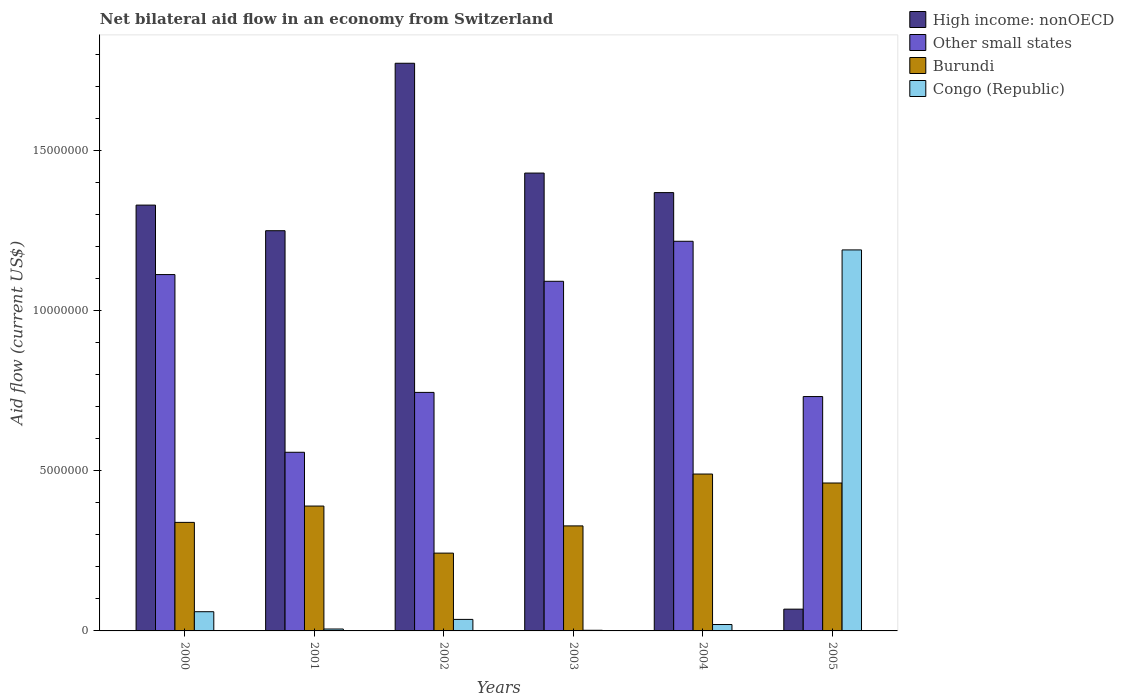How many different coloured bars are there?
Provide a short and direct response. 4. How many groups of bars are there?
Provide a short and direct response. 6. How many bars are there on the 5th tick from the left?
Offer a terse response. 4. What is the label of the 3rd group of bars from the left?
Provide a short and direct response. 2002. In how many cases, is the number of bars for a given year not equal to the number of legend labels?
Your answer should be compact. 0. What is the net bilateral aid flow in Other small states in 2000?
Keep it short and to the point. 1.11e+07. Across all years, what is the maximum net bilateral aid flow in Burundi?
Provide a short and direct response. 4.90e+06. Across all years, what is the minimum net bilateral aid flow in High income: nonOECD?
Provide a short and direct response. 6.80e+05. In which year was the net bilateral aid flow in Other small states minimum?
Offer a very short reply. 2001. What is the total net bilateral aid flow in Congo (Republic) in the graph?
Your response must be concise. 1.31e+07. What is the difference between the net bilateral aid flow in High income: nonOECD in 2001 and the net bilateral aid flow in Congo (Republic) in 2002?
Make the answer very short. 1.21e+07. What is the average net bilateral aid flow in Other small states per year?
Offer a very short reply. 9.10e+06. In the year 2003, what is the difference between the net bilateral aid flow in Burundi and net bilateral aid flow in High income: nonOECD?
Your response must be concise. -1.10e+07. What is the difference between the highest and the second highest net bilateral aid flow in Other small states?
Your answer should be very brief. 1.04e+06. What is the difference between the highest and the lowest net bilateral aid flow in High income: nonOECD?
Make the answer very short. 1.70e+07. In how many years, is the net bilateral aid flow in Other small states greater than the average net bilateral aid flow in Other small states taken over all years?
Provide a succinct answer. 3. Is the sum of the net bilateral aid flow in Burundi in 2002 and 2003 greater than the maximum net bilateral aid flow in Congo (Republic) across all years?
Your answer should be compact. No. Is it the case that in every year, the sum of the net bilateral aid flow in Congo (Republic) and net bilateral aid flow in High income: nonOECD is greater than the sum of net bilateral aid flow in Burundi and net bilateral aid flow in Other small states?
Keep it short and to the point. No. What does the 1st bar from the left in 2005 represents?
Offer a terse response. High income: nonOECD. What does the 3rd bar from the right in 2003 represents?
Give a very brief answer. Other small states. How many bars are there?
Make the answer very short. 24. How many years are there in the graph?
Ensure brevity in your answer.  6. What is the difference between two consecutive major ticks on the Y-axis?
Keep it short and to the point. 5.00e+06. Are the values on the major ticks of Y-axis written in scientific E-notation?
Provide a short and direct response. No. Does the graph contain grids?
Give a very brief answer. No. Where does the legend appear in the graph?
Give a very brief answer. Top right. What is the title of the graph?
Keep it short and to the point. Net bilateral aid flow in an economy from Switzerland. Does "Norway" appear as one of the legend labels in the graph?
Your answer should be very brief. No. What is the label or title of the Y-axis?
Ensure brevity in your answer.  Aid flow (current US$). What is the Aid flow (current US$) of High income: nonOECD in 2000?
Offer a terse response. 1.33e+07. What is the Aid flow (current US$) of Other small states in 2000?
Offer a terse response. 1.11e+07. What is the Aid flow (current US$) of Burundi in 2000?
Your answer should be very brief. 3.39e+06. What is the Aid flow (current US$) in High income: nonOECD in 2001?
Ensure brevity in your answer.  1.25e+07. What is the Aid flow (current US$) of Other small states in 2001?
Offer a terse response. 5.58e+06. What is the Aid flow (current US$) of Burundi in 2001?
Your response must be concise. 3.90e+06. What is the Aid flow (current US$) in Congo (Republic) in 2001?
Provide a short and direct response. 6.00e+04. What is the Aid flow (current US$) in High income: nonOECD in 2002?
Keep it short and to the point. 1.77e+07. What is the Aid flow (current US$) of Other small states in 2002?
Your response must be concise. 7.45e+06. What is the Aid flow (current US$) in Burundi in 2002?
Your answer should be very brief. 2.43e+06. What is the Aid flow (current US$) of Congo (Republic) in 2002?
Make the answer very short. 3.60e+05. What is the Aid flow (current US$) in High income: nonOECD in 2003?
Provide a succinct answer. 1.43e+07. What is the Aid flow (current US$) of Other small states in 2003?
Provide a succinct answer. 1.09e+07. What is the Aid flow (current US$) in Burundi in 2003?
Your answer should be compact. 3.28e+06. What is the Aid flow (current US$) of High income: nonOECD in 2004?
Make the answer very short. 1.37e+07. What is the Aid flow (current US$) in Other small states in 2004?
Your answer should be very brief. 1.22e+07. What is the Aid flow (current US$) in Burundi in 2004?
Keep it short and to the point. 4.90e+06. What is the Aid flow (current US$) of High income: nonOECD in 2005?
Offer a terse response. 6.80e+05. What is the Aid flow (current US$) in Other small states in 2005?
Your answer should be very brief. 7.32e+06. What is the Aid flow (current US$) in Burundi in 2005?
Provide a succinct answer. 4.62e+06. What is the Aid flow (current US$) of Congo (Republic) in 2005?
Give a very brief answer. 1.19e+07. Across all years, what is the maximum Aid flow (current US$) in High income: nonOECD?
Offer a very short reply. 1.77e+07. Across all years, what is the maximum Aid flow (current US$) in Other small states?
Provide a short and direct response. 1.22e+07. Across all years, what is the maximum Aid flow (current US$) in Burundi?
Your response must be concise. 4.90e+06. Across all years, what is the maximum Aid flow (current US$) in Congo (Republic)?
Keep it short and to the point. 1.19e+07. Across all years, what is the minimum Aid flow (current US$) in High income: nonOECD?
Ensure brevity in your answer.  6.80e+05. Across all years, what is the minimum Aid flow (current US$) of Other small states?
Your answer should be compact. 5.58e+06. Across all years, what is the minimum Aid flow (current US$) in Burundi?
Make the answer very short. 2.43e+06. Across all years, what is the minimum Aid flow (current US$) of Congo (Republic)?
Provide a succinct answer. 2.00e+04. What is the total Aid flow (current US$) in High income: nonOECD in the graph?
Your answer should be compact. 7.22e+07. What is the total Aid flow (current US$) in Other small states in the graph?
Your answer should be compact. 5.46e+07. What is the total Aid flow (current US$) in Burundi in the graph?
Your answer should be very brief. 2.25e+07. What is the total Aid flow (current US$) of Congo (Republic) in the graph?
Keep it short and to the point. 1.31e+07. What is the difference between the Aid flow (current US$) in High income: nonOECD in 2000 and that in 2001?
Your answer should be compact. 8.00e+05. What is the difference between the Aid flow (current US$) of Other small states in 2000 and that in 2001?
Keep it short and to the point. 5.55e+06. What is the difference between the Aid flow (current US$) of Burundi in 2000 and that in 2001?
Offer a terse response. -5.10e+05. What is the difference between the Aid flow (current US$) of Congo (Republic) in 2000 and that in 2001?
Your response must be concise. 5.40e+05. What is the difference between the Aid flow (current US$) in High income: nonOECD in 2000 and that in 2002?
Keep it short and to the point. -4.43e+06. What is the difference between the Aid flow (current US$) of Other small states in 2000 and that in 2002?
Your response must be concise. 3.68e+06. What is the difference between the Aid flow (current US$) of Burundi in 2000 and that in 2002?
Your answer should be very brief. 9.60e+05. What is the difference between the Aid flow (current US$) of Congo (Republic) in 2000 and that in 2002?
Your answer should be very brief. 2.40e+05. What is the difference between the Aid flow (current US$) in High income: nonOECD in 2000 and that in 2003?
Your answer should be compact. -1.00e+06. What is the difference between the Aid flow (current US$) of Other small states in 2000 and that in 2003?
Your response must be concise. 2.10e+05. What is the difference between the Aid flow (current US$) in Congo (Republic) in 2000 and that in 2003?
Provide a succinct answer. 5.80e+05. What is the difference between the Aid flow (current US$) of High income: nonOECD in 2000 and that in 2004?
Ensure brevity in your answer.  -3.90e+05. What is the difference between the Aid flow (current US$) of Other small states in 2000 and that in 2004?
Provide a short and direct response. -1.04e+06. What is the difference between the Aid flow (current US$) in Burundi in 2000 and that in 2004?
Your answer should be very brief. -1.51e+06. What is the difference between the Aid flow (current US$) of High income: nonOECD in 2000 and that in 2005?
Your answer should be compact. 1.26e+07. What is the difference between the Aid flow (current US$) in Other small states in 2000 and that in 2005?
Ensure brevity in your answer.  3.81e+06. What is the difference between the Aid flow (current US$) of Burundi in 2000 and that in 2005?
Your answer should be compact. -1.23e+06. What is the difference between the Aid flow (current US$) of Congo (Republic) in 2000 and that in 2005?
Your answer should be very brief. -1.13e+07. What is the difference between the Aid flow (current US$) in High income: nonOECD in 2001 and that in 2002?
Offer a terse response. -5.23e+06. What is the difference between the Aid flow (current US$) of Other small states in 2001 and that in 2002?
Keep it short and to the point. -1.87e+06. What is the difference between the Aid flow (current US$) of Burundi in 2001 and that in 2002?
Offer a very short reply. 1.47e+06. What is the difference between the Aid flow (current US$) of Congo (Republic) in 2001 and that in 2002?
Provide a succinct answer. -3.00e+05. What is the difference between the Aid flow (current US$) of High income: nonOECD in 2001 and that in 2003?
Provide a short and direct response. -1.80e+06. What is the difference between the Aid flow (current US$) in Other small states in 2001 and that in 2003?
Your response must be concise. -5.34e+06. What is the difference between the Aid flow (current US$) of Burundi in 2001 and that in 2003?
Provide a short and direct response. 6.20e+05. What is the difference between the Aid flow (current US$) of Congo (Republic) in 2001 and that in 2003?
Offer a terse response. 4.00e+04. What is the difference between the Aid flow (current US$) in High income: nonOECD in 2001 and that in 2004?
Offer a terse response. -1.19e+06. What is the difference between the Aid flow (current US$) in Other small states in 2001 and that in 2004?
Your response must be concise. -6.59e+06. What is the difference between the Aid flow (current US$) in Congo (Republic) in 2001 and that in 2004?
Ensure brevity in your answer.  -1.40e+05. What is the difference between the Aid flow (current US$) of High income: nonOECD in 2001 and that in 2005?
Make the answer very short. 1.18e+07. What is the difference between the Aid flow (current US$) in Other small states in 2001 and that in 2005?
Provide a succinct answer. -1.74e+06. What is the difference between the Aid flow (current US$) in Burundi in 2001 and that in 2005?
Provide a succinct answer. -7.20e+05. What is the difference between the Aid flow (current US$) in Congo (Republic) in 2001 and that in 2005?
Ensure brevity in your answer.  -1.18e+07. What is the difference between the Aid flow (current US$) in High income: nonOECD in 2002 and that in 2003?
Your answer should be very brief. 3.43e+06. What is the difference between the Aid flow (current US$) of Other small states in 2002 and that in 2003?
Your answer should be very brief. -3.47e+06. What is the difference between the Aid flow (current US$) in Burundi in 2002 and that in 2003?
Offer a terse response. -8.50e+05. What is the difference between the Aid flow (current US$) in Congo (Republic) in 2002 and that in 2003?
Offer a very short reply. 3.40e+05. What is the difference between the Aid flow (current US$) of High income: nonOECD in 2002 and that in 2004?
Provide a succinct answer. 4.04e+06. What is the difference between the Aid flow (current US$) in Other small states in 2002 and that in 2004?
Offer a very short reply. -4.72e+06. What is the difference between the Aid flow (current US$) in Burundi in 2002 and that in 2004?
Offer a very short reply. -2.47e+06. What is the difference between the Aid flow (current US$) in High income: nonOECD in 2002 and that in 2005?
Your response must be concise. 1.70e+07. What is the difference between the Aid flow (current US$) in Other small states in 2002 and that in 2005?
Keep it short and to the point. 1.30e+05. What is the difference between the Aid flow (current US$) in Burundi in 2002 and that in 2005?
Your answer should be very brief. -2.19e+06. What is the difference between the Aid flow (current US$) in Congo (Republic) in 2002 and that in 2005?
Offer a terse response. -1.15e+07. What is the difference between the Aid flow (current US$) of High income: nonOECD in 2003 and that in 2004?
Keep it short and to the point. 6.10e+05. What is the difference between the Aid flow (current US$) in Other small states in 2003 and that in 2004?
Your answer should be very brief. -1.25e+06. What is the difference between the Aid flow (current US$) of Burundi in 2003 and that in 2004?
Offer a very short reply. -1.62e+06. What is the difference between the Aid flow (current US$) in Congo (Republic) in 2003 and that in 2004?
Keep it short and to the point. -1.80e+05. What is the difference between the Aid flow (current US$) in High income: nonOECD in 2003 and that in 2005?
Make the answer very short. 1.36e+07. What is the difference between the Aid flow (current US$) of Other small states in 2003 and that in 2005?
Ensure brevity in your answer.  3.60e+06. What is the difference between the Aid flow (current US$) in Burundi in 2003 and that in 2005?
Your answer should be compact. -1.34e+06. What is the difference between the Aid flow (current US$) in Congo (Republic) in 2003 and that in 2005?
Offer a very short reply. -1.19e+07. What is the difference between the Aid flow (current US$) in High income: nonOECD in 2004 and that in 2005?
Your answer should be compact. 1.30e+07. What is the difference between the Aid flow (current US$) of Other small states in 2004 and that in 2005?
Offer a terse response. 4.85e+06. What is the difference between the Aid flow (current US$) of Congo (Republic) in 2004 and that in 2005?
Provide a succinct answer. -1.17e+07. What is the difference between the Aid flow (current US$) of High income: nonOECD in 2000 and the Aid flow (current US$) of Other small states in 2001?
Your response must be concise. 7.72e+06. What is the difference between the Aid flow (current US$) in High income: nonOECD in 2000 and the Aid flow (current US$) in Burundi in 2001?
Your answer should be very brief. 9.40e+06. What is the difference between the Aid flow (current US$) of High income: nonOECD in 2000 and the Aid flow (current US$) of Congo (Republic) in 2001?
Offer a terse response. 1.32e+07. What is the difference between the Aid flow (current US$) in Other small states in 2000 and the Aid flow (current US$) in Burundi in 2001?
Offer a very short reply. 7.23e+06. What is the difference between the Aid flow (current US$) of Other small states in 2000 and the Aid flow (current US$) of Congo (Republic) in 2001?
Ensure brevity in your answer.  1.11e+07. What is the difference between the Aid flow (current US$) of Burundi in 2000 and the Aid flow (current US$) of Congo (Republic) in 2001?
Make the answer very short. 3.33e+06. What is the difference between the Aid flow (current US$) of High income: nonOECD in 2000 and the Aid flow (current US$) of Other small states in 2002?
Provide a succinct answer. 5.85e+06. What is the difference between the Aid flow (current US$) of High income: nonOECD in 2000 and the Aid flow (current US$) of Burundi in 2002?
Your answer should be compact. 1.09e+07. What is the difference between the Aid flow (current US$) in High income: nonOECD in 2000 and the Aid flow (current US$) in Congo (Republic) in 2002?
Keep it short and to the point. 1.29e+07. What is the difference between the Aid flow (current US$) in Other small states in 2000 and the Aid flow (current US$) in Burundi in 2002?
Your answer should be very brief. 8.70e+06. What is the difference between the Aid flow (current US$) in Other small states in 2000 and the Aid flow (current US$) in Congo (Republic) in 2002?
Give a very brief answer. 1.08e+07. What is the difference between the Aid flow (current US$) of Burundi in 2000 and the Aid flow (current US$) of Congo (Republic) in 2002?
Your answer should be compact. 3.03e+06. What is the difference between the Aid flow (current US$) of High income: nonOECD in 2000 and the Aid flow (current US$) of Other small states in 2003?
Your answer should be compact. 2.38e+06. What is the difference between the Aid flow (current US$) in High income: nonOECD in 2000 and the Aid flow (current US$) in Burundi in 2003?
Offer a terse response. 1.00e+07. What is the difference between the Aid flow (current US$) in High income: nonOECD in 2000 and the Aid flow (current US$) in Congo (Republic) in 2003?
Your answer should be compact. 1.33e+07. What is the difference between the Aid flow (current US$) of Other small states in 2000 and the Aid flow (current US$) of Burundi in 2003?
Provide a succinct answer. 7.85e+06. What is the difference between the Aid flow (current US$) in Other small states in 2000 and the Aid flow (current US$) in Congo (Republic) in 2003?
Give a very brief answer. 1.11e+07. What is the difference between the Aid flow (current US$) of Burundi in 2000 and the Aid flow (current US$) of Congo (Republic) in 2003?
Ensure brevity in your answer.  3.37e+06. What is the difference between the Aid flow (current US$) in High income: nonOECD in 2000 and the Aid flow (current US$) in Other small states in 2004?
Give a very brief answer. 1.13e+06. What is the difference between the Aid flow (current US$) in High income: nonOECD in 2000 and the Aid flow (current US$) in Burundi in 2004?
Provide a succinct answer. 8.40e+06. What is the difference between the Aid flow (current US$) in High income: nonOECD in 2000 and the Aid flow (current US$) in Congo (Republic) in 2004?
Ensure brevity in your answer.  1.31e+07. What is the difference between the Aid flow (current US$) of Other small states in 2000 and the Aid flow (current US$) of Burundi in 2004?
Provide a succinct answer. 6.23e+06. What is the difference between the Aid flow (current US$) in Other small states in 2000 and the Aid flow (current US$) in Congo (Republic) in 2004?
Offer a terse response. 1.09e+07. What is the difference between the Aid flow (current US$) in Burundi in 2000 and the Aid flow (current US$) in Congo (Republic) in 2004?
Offer a terse response. 3.19e+06. What is the difference between the Aid flow (current US$) of High income: nonOECD in 2000 and the Aid flow (current US$) of Other small states in 2005?
Offer a terse response. 5.98e+06. What is the difference between the Aid flow (current US$) of High income: nonOECD in 2000 and the Aid flow (current US$) of Burundi in 2005?
Your answer should be very brief. 8.68e+06. What is the difference between the Aid flow (current US$) in High income: nonOECD in 2000 and the Aid flow (current US$) in Congo (Republic) in 2005?
Offer a very short reply. 1.40e+06. What is the difference between the Aid flow (current US$) of Other small states in 2000 and the Aid flow (current US$) of Burundi in 2005?
Offer a very short reply. 6.51e+06. What is the difference between the Aid flow (current US$) of Other small states in 2000 and the Aid flow (current US$) of Congo (Republic) in 2005?
Keep it short and to the point. -7.70e+05. What is the difference between the Aid flow (current US$) in Burundi in 2000 and the Aid flow (current US$) in Congo (Republic) in 2005?
Keep it short and to the point. -8.51e+06. What is the difference between the Aid flow (current US$) in High income: nonOECD in 2001 and the Aid flow (current US$) in Other small states in 2002?
Your response must be concise. 5.05e+06. What is the difference between the Aid flow (current US$) in High income: nonOECD in 2001 and the Aid flow (current US$) in Burundi in 2002?
Your answer should be very brief. 1.01e+07. What is the difference between the Aid flow (current US$) in High income: nonOECD in 2001 and the Aid flow (current US$) in Congo (Republic) in 2002?
Ensure brevity in your answer.  1.21e+07. What is the difference between the Aid flow (current US$) of Other small states in 2001 and the Aid flow (current US$) of Burundi in 2002?
Provide a short and direct response. 3.15e+06. What is the difference between the Aid flow (current US$) of Other small states in 2001 and the Aid flow (current US$) of Congo (Republic) in 2002?
Offer a terse response. 5.22e+06. What is the difference between the Aid flow (current US$) of Burundi in 2001 and the Aid flow (current US$) of Congo (Republic) in 2002?
Provide a succinct answer. 3.54e+06. What is the difference between the Aid flow (current US$) in High income: nonOECD in 2001 and the Aid flow (current US$) in Other small states in 2003?
Ensure brevity in your answer.  1.58e+06. What is the difference between the Aid flow (current US$) of High income: nonOECD in 2001 and the Aid flow (current US$) of Burundi in 2003?
Offer a very short reply. 9.22e+06. What is the difference between the Aid flow (current US$) in High income: nonOECD in 2001 and the Aid flow (current US$) in Congo (Republic) in 2003?
Keep it short and to the point. 1.25e+07. What is the difference between the Aid flow (current US$) in Other small states in 2001 and the Aid flow (current US$) in Burundi in 2003?
Ensure brevity in your answer.  2.30e+06. What is the difference between the Aid flow (current US$) in Other small states in 2001 and the Aid flow (current US$) in Congo (Republic) in 2003?
Provide a succinct answer. 5.56e+06. What is the difference between the Aid flow (current US$) of Burundi in 2001 and the Aid flow (current US$) of Congo (Republic) in 2003?
Provide a short and direct response. 3.88e+06. What is the difference between the Aid flow (current US$) of High income: nonOECD in 2001 and the Aid flow (current US$) of Other small states in 2004?
Provide a short and direct response. 3.30e+05. What is the difference between the Aid flow (current US$) of High income: nonOECD in 2001 and the Aid flow (current US$) of Burundi in 2004?
Provide a short and direct response. 7.60e+06. What is the difference between the Aid flow (current US$) in High income: nonOECD in 2001 and the Aid flow (current US$) in Congo (Republic) in 2004?
Your answer should be very brief. 1.23e+07. What is the difference between the Aid flow (current US$) in Other small states in 2001 and the Aid flow (current US$) in Burundi in 2004?
Make the answer very short. 6.80e+05. What is the difference between the Aid flow (current US$) in Other small states in 2001 and the Aid flow (current US$) in Congo (Republic) in 2004?
Your answer should be very brief. 5.38e+06. What is the difference between the Aid flow (current US$) of Burundi in 2001 and the Aid flow (current US$) of Congo (Republic) in 2004?
Provide a succinct answer. 3.70e+06. What is the difference between the Aid flow (current US$) in High income: nonOECD in 2001 and the Aid flow (current US$) in Other small states in 2005?
Your answer should be very brief. 5.18e+06. What is the difference between the Aid flow (current US$) in High income: nonOECD in 2001 and the Aid flow (current US$) in Burundi in 2005?
Ensure brevity in your answer.  7.88e+06. What is the difference between the Aid flow (current US$) in Other small states in 2001 and the Aid flow (current US$) in Burundi in 2005?
Your response must be concise. 9.60e+05. What is the difference between the Aid flow (current US$) in Other small states in 2001 and the Aid flow (current US$) in Congo (Republic) in 2005?
Provide a succinct answer. -6.32e+06. What is the difference between the Aid flow (current US$) of Burundi in 2001 and the Aid flow (current US$) of Congo (Republic) in 2005?
Provide a succinct answer. -8.00e+06. What is the difference between the Aid flow (current US$) of High income: nonOECD in 2002 and the Aid flow (current US$) of Other small states in 2003?
Give a very brief answer. 6.81e+06. What is the difference between the Aid flow (current US$) in High income: nonOECD in 2002 and the Aid flow (current US$) in Burundi in 2003?
Your answer should be very brief. 1.44e+07. What is the difference between the Aid flow (current US$) of High income: nonOECD in 2002 and the Aid flow (current US$) of Congo (Republic) in 2003?
Your answer should be very brief. 1.77e+07. What is the difference between the Aid flow (current US$) of Other small states in 2002 and the Aid flow (current US$) of Burundi in 2003?
Your response must be concise. 4.17e+06. What is the difference between the Aid flow (current US$) of Other small states in 2002 and the Aid flow (current US$) of Congo (Republic) in 2003?
Your answer should be compact. 7.43e+06. What is the difference between the Aid flow (current US$) of Burundi in 2002 and the Aid flow (current US$) of Congo (Republic) in 2003?
Keep it short and to the point. 2.41e+06. What is the difference between the Aid flow (current US$) in High income: nonOECD in 2002 and the Aid flow (current US$) in Other small states in 2004?
Make the answer very short. 5.56e+06. What is the difference between the Aid flow (current US$) in High income: nonOECD in 2002 and the Aid flow (current US$) in Burundi in 2004?
Provide a short and direct response. 1.28e+07. What is the difference between the Aid flow (current US$) in High income: nonOECD in 2002 and the Aid flow (current US$) in Congo (Republic) in 2004?
Offer a terse response. 1.75e+07. What is the difference between the Aid flow (current US$) in Other small states in 2002 and the Aid flow (current US$) in Burundi in 2004?
Your response must be concise. 2.55e+06. What is the difference between the Aid flow (current US$) of Other small states in 2002 and the Aid flow (current US$) of Congo (Republic) in 2004?
Provide a succinct answer. 7.25e+06. What is the difference between the Aid flow (current US$) of Burundi in 2002 and the Aid flow (current US$) of Congo (Republic) in 2004?
Make the answer very short. 2.23e+06. What is the difference between the Aid flow (current US$) of High income: nonOECD in 2002 and the Aid flow (current US$) of Other small states in 2005?
Your response must be concise. 1.04e+07. What is the difference between the Aid flow (current US$) of High income: nonOECD in 2002 and the Aid flow (current US$) of Burundi in 2005?
Ensure brevity in your answer.  1.31e+07. What is the difference between the Aid flow (current US$) of High income: nonOECD in 2002 and the Aid flow (current US$) of Congo (Republic) in 2005?
Offer a very short reply. 5.83e+06. What is the difference between the Aid flow (current US$) in Other small states in 2002 and the Aid flow (current US$) in Burundi in 2005?
Make the answer very short. 2.83e+06. What is the difference between the Aid flow (current US$) in Other small states in 2002 and the Aid flow (current US$) in Congo (Republic) in 2005?
Your answer should be compact. -4.45e+06. What is the difference between the Aid flow (current US$) of Burundi in 2002 and the Aid flow (current US$) of Congo (Republic) in 2005?
Give a very brief answer. -9.47e+06. What is the difference between the Aid flow (current US$) of High income: nonOECD in 2003 and the Aid flow (current US$) of Other small states in 2004?
Your answer should be very brief. 2.13e+06. What is the difference between the Aid flow (current US$) in High income: nonOECD in 2003 and the Aid flow (current US$) in Burundi in 2004?
Keep it short and to the point. 9.40e+06. What is the difference between the Aid flow (current US$) of High income: nonOECD in 2003 and the Aid flow (current US$) of Congo (Republic) in 2004?
Make the answer very short. 1.41e+07. What is the difference between the Aid flow (current US$) of Other small states in 2003 and the Aid flow (current US$) of Burundi in 2004?
Ensure brevity in your answer.  6.02e+06. What is the difference between the Aid flow (current US$) of Other small states in 2003 and the Aid flow (current US$) of Congo (Republic) in 2004?
Provide a short and direct response. 1.07e+07. What is the difference between the Aid flow (current US$) in Burundi in 2003 and the Aid flow (current US$) in Congo (Republic) in 2004?
Make the answer very short. 3.08e+06. What is the difference between the Aid flow (current US$) in High income: nonOECD in 2003 and the Aid flow (current US$) in Other small states in 2005?
Keep it short and to the point. 6.98e+06. What is the difference between the Aid flow (current US$) in High income: nonOECD in 2003 and the Aid flow (current US$) in Burundi in 2005?
Offer a terse response. 9.68e+06. What is the difference between the Aid flow (current US$) in High income: nonOECD in 2003 and the Aid flow (current US$) in Congo (Republic) in 2005?
Your response must be concise. 2.40e+06. What is the difference between the Aid flow (current US$) in Other small states in 2003 and the Aid flow (current US$) in Burundi in 2005?
Provide a succinct answer. 6.30e+06. What is the difference between the Aid flow (current US$) in Other small states in 2003 and the Aid flow (current US$) in Congo (Republic) in 2005?
Provide a succinct answer. -9.80e+05. What is the difference between the Aid flow (current US$) of Burundi in 2003 and the Aid flow (current US$) of Congo (Republic) in 2005?
Ensure brevity in your answer.  -8.62e+06. What is the difference between the Aid flow (current US$) of High income: nonOECD in 2004 and the Aid flow (current US$) of Other small states in 2005?
Ensure brevity in your answer.  6.37e+06. What is the difference between the Aid flow (current US$) of High income: nonOECD in 2004 and the Aid flow (current US$) of Burundi in 2005?
Give a very brief answer. 9.07e+06. What is the difference between the Aid flow (current US$) of High income: nonOECD in 2004 and the Aid flow (current US$) of Congo (Republic) in 2005?
Your response must be concise. 1.79e+06. What is the difference between the Aid flow (current US$) of Other small states in 2004 and the Aid flow (current US$) of Burundi in 2005?
Provide a short and direct response. 7.55e+06. What is the difference between the Aid flow (current US$) of Other small states in 2004 and the Aid flow (current US$) of Congo (Republic) in 2005?
Your answer should be compact. 2.70e+05. What is the difference between the Aid flow (current US$) in Burundi in 2004 and the Aid flow (current US$) in Congo (Republic) in 2005?
Your answer should be very brief. -7.00e+06. What is the average Aid flow (current US$) of High income: nonOECD per year?
Provide a short and direct response. 1.20e+07. What is the average Aid flow (current US$) in Other small states per year?
Offer a very short reply. 9.10e+06. What is the average Aid flow (current US$) of Burundi per year?
Give a very brief answer. 3.75e+06. What is the average Aid flow (current US$) in Congo (Republic) per year?
Provide a succinct answer. 2.19e+06. In the year 2000, what is the difference between the Aid flow (current US$) of High income: nonOECD and Aid flow (current US$) of Other small states?
Keep it short and to the point. 2.17e+06. In the year 2000, what is the difference between the Aid flow (current US$) of High income: nonOECD and Aid flow (current US$) of Burundi?
Make the answer very short. 9.91e+06. In the year 2000, what is the difference between the Aid flow (current US$) in High income: nonOECD and Aid flow (current US$) in Congo (Republic)?
Offer a terse response. 1.27e+07. In the year 2000, what is the difference between the Aid flow (current US$) of Other small states and Aid flow (current US$) of Burundi?
Your response must be concise. 7.74e+06. In the year 2000, what is the difference between the Aid flow (current US$) in Other small states and Aid flow (current US$) in Congo (Republic)?
Offer a very short reply. 1.05e+07. In the year 2000, what is the difference between the Aid flow (current US$) in Burundi and Aid flow (current US$) in Congo (Republic)?
Provide a short and direct response. 2.79e+06. In the year 2001, what is the difference between the Aid flow (current US$) in High income: nonOECD and Aid flow (current US$) in Other small states?
Keep it short and to the point. 6.92e+06. In the year 2001, what is the difference between the Aid flow (current US$) in High income: nonOECD and Aid flow (current US$) in Burundi?
Your response must be concise. 8.60e+06. In the year 2001, what is the difference between the Aid flow (current US$) in High income: nonOECD and Aid flow (current US$) in Congo (Republic)?
Offer a very short reply. 1.24e+07. In the year 2001, what is the difference between the Aid flow (current US$) in Other small states and Aid flow (current US$) in Burundi?
Make the answer very short. 1.68e+06. In the year 2001, what is the difference between the Aid flow (current US$) in Other small states and Aid flow (current US$) in Congo (Republic)?
Your answer should be very brief. 5.52e+06. In the year 2001, what is the difference between the Aid flow (current US$) of Burundi and Aid flow (current US$) of Congo (Republic)?
Offer a terse response. 3.84e+06. In the year 2002, what is the difference between the Aid flow (current US$) of High income: nonOECD and Aid flow (current US$) of Other small states?
Make the answer very short. 1.03e+07. In the year 2002, what is the difference between the Aid flow (current US$) in High income: nonOECD and Aid flow (current US$) in Burundi?
Provide a short and direct response. 1.53e+07. In the year 2002, what is the difference between the Aid flow (current US$) of High income: nonOECD and Aid flow (current US$) of Congo (Republic)?
Provide a short and direct response. 1.74e+07. In the year 2002, what is the difference between the Aid flow (current US$) in Other small states and Aid flow (current US$) in Burundi?
Provide a succinct answer. 5.02e+06. In the year 2002, what is the difference between the Aid flow (current US$) of Other small states and Aid flow (current US$) of Congo (Republic)?
Offer a very short reply. 7.09e+06. In the year 2002, what is the difference between the Aid flow (current US$) in Burundi and Aid flow (current US$) in Congo (Republic)?
Offer a terse response. 2.07e+06. In the year 2003, what is the difference between the Aid flow (current US$) in High income: nonOECD and Aid flow (current US$) in Other small states?
Your response must be concise. 3.38e+06. In the year 2003, what is the difference between the Aid flow (current US$) in High income: nonOECD and Aid flow (current US$) in Burundi?
Make the answer very short. 1.10e+07. In the year 2003, what is the difference between the Aid flow (current US$) of High income: nonOECD and Aid flow (current US$) of Congo (Republic)?
Offer a terse response. 1.43e+07. In the year 2003, what is the difference between the Aid flow (current US$) of Other small states and Aid flow (current US$) of Burundi?
Provide a succinct answer. 7.64e+06. In the year 2003, what is the difference between the Aid flow (current US$) of Other small states and Aid flow (current US$) of Congo (Republic)?
Offer a very short reply. 1.09e+07. In the year 2003, what is the difference between the Aid flow (current US$) of Burundi and Aid flow (current US$) of Congo (Republic)?
Make the answer very short. 3.26e+06. In the year 2004, what is the difference between the Aid flow (current US$) of High income: nonOECD and Aid flow (current US$) of Other small states?
Offer a very short reply. 1.52e+06. In the year 2004, what is the difference between the Aid flow (current US$) of High income: nonOECD and Aid flow (current US$) of Burundi?
Your answer should be compact. 8.79e+06. In the year 2004, what is the difference between the Aid flow (current US$) in High income: nonOECD and Aid flow (current US$) in Congo (Republic)?
Your response must be concise. 1.35e+07. In the year 2004, what is the difference between the Aid flow (current US$) of Other small states and Aid flow (current US$) of Burundi?
Give a very brief answer. 7.27e+06. In the year 2004, what is the difference between the Aid flow (current US$) of Other small states and Aid flow (current US$) of Congo (Republic)?
Your answer should be very brief. 1.20e+07. In the year 2004, what is the difference between the Aid flow (current US$) in Burundi and Aid flow (current US$) in Congo (Republic)?
Your answer should be compact. 4.70e+06. In the year 2005, what is the difference between the Aid flow (current US$) of High income: nonOECD and Aid flow (current US$) of Other small states?
Your response must be concise. -6.64e+06. In the year 2005, what is the difference between the Aid flow (current US$) of High income: nonOECD and Aid flow (current US$) of Burundi?
Offer a terse response. -3.94e+06. In the year 2005, what is the difference between the Aid flow (current US$) of High income: nonOECD and Aid flow (current US$) of Congo (Republic)?
Make the answer very short. -1.12e+07. In the year 2005, what is the difference between the Aid flow (current US$) of Other small states and Aid flow (current US$) of Burundi?
Ensure brevity in your answer.  2.70e+06. In the year 2005, what is the difference between the Aid flow (current US$) in Other small states and Aid flow (current US$) in Congo (Republic)?
Your response must be concise. -4.58e+06. In the year 2005, what is the difference between the Aid flow (current US$) in Burundi and Aid flow (current US$) in Congo (Republic)?
Your answer should be compact. -7.28e+06. What is the ratio of the Aid flow (current US$) in High income: nonOECD in 2000 to that in 2001?
Provide a short and direct response. 1.06. What is the ratio of the Aid flow (current US$) of Other small states in 2000 to that in 2001?
Keep it short and to the point. 1.99. What is the ratio of the Aid flow (current US$) in Burundi in 2000 to that in 2001?
Keep it short and to the point. 0.87. What is the ratio of the Aid flow (current US$) in Congo (Republic) in 2000 to that in 2001?
Give a very brief answer. 10. What is the ratio of the Aid flow (current US$) of High income: nonOECD in 2000 to that in 2002?
Your response must be concise. 0.75. What is the ratio of the Aid flow (current US$) in Other small states in 2000 to that in 2002?
Your response must be concise. 1.49. What is the ratio of the Aid flow (current US$) of Burundi in 2000 to that in 2002?
Your answer should be very brief. 1.4. What is the ratio of the Aid flow (current US$) in Congo (Republic) in 2000 to that in 2002?
Keep it short and to the point. 1.67. What is the ratio of the Aid flow (current US$) in High income: nonOECD in 2000 to that in 2003?
Ensure brevity in your answer.  0.93. What is the ratio of the Aid flow (current US$) in Other small states in 2000 to that in 2003?
Ensure brevity in your answer.  1.02. What is the ratio of the Aid flow (current US$) of Burundi in 2000 to that in 2003?
Provide a short and direct response. 1.03. What is the ratio of the Aid flow (current US$) in Congo (Republic) in 2000 to that in 2003?
Provide a succinct answer. 30. What is the ratio of the Aid flow (current US$) of High income: nonOECD in 2000 to that in 2004?
Make the answer very short. 0.97. What is the ratio of the Aid flow (current US$) in Other small states in 2000 to that in 2004?
Keep it short and to the point. 0.91. What is the ratio of the Aid flow (current US$) in Burundi in 2000 to that in 2004?
Provide a short and direct response. 0.69. What is the ratio of the Aid flow (current US$) in High income: nonOECD in 2000 to that in 2005?
Ensure brevity in your answer.  19.56. What is the ratio of the Aid flow (current US$) of Other small states in 2000 to that in 2005?
Make the answer very short. 1.52. What is the ratio of the Aid flow (current US$) of Burundi in 2000 to that in 2005?
Your answer should be very brief. 0.73. What is the ratio of the Aid flow (current US$) of Congo (Republic) in 2000 to that in 2005?
Keep it short and to the point. 0.05. What is the ratio of the Aid flow (current US$) of High income: nonOECD in 2001 to that in 2002?
Make the answer very short. 0.7. What is the ratio of the Aid flow (current US$) of Other small states in 2001 to that in 2002?
Provide a short and direct response. 0.75. What is the ratio of the Aid flow (current US$) in Burundi in 2001 to that in 2002?
Keep it short and to the point. 1.6. What is the ratio of the Aid flow (current US$) of High income: nonOECD in 2001 to that in 2003?
Keep it short and to the point. 0.87. What is the ratio of the Aid flow (current US$) of Other small states in 2001 to that in 2003?
Your response must be concise. 0.51. What is the ratio of the Aid flow (current US$) of Burundi in 2001 to that in 2003?
Your answer should be very brief. 1.19. What is the ratio of the Aid flow (current US$) in Congo (Republic) in 2001 to that in 2003?
Ensure brevity in your answer.  3. What is the ratio of the Aid flow (current US$) in High income: nonOECD in 2001 to that in 2004?
Your answer should be very brief. 0.91. What is the ratio of the Aid flow (current US$) of Other small states in 2001 to that in 2004?
Ensure brevity in your answer.  0.46. What is the ratio of the Aid flow (current US$) of Burundi in 2001 to that in 2004?
Offer a terse response. 0.8. What is the ratio of the Aid flow (current US$) of High income: nonOECD in 2001 to that in 2005?
Your response must be concise. 18.38. What is the ratio of the Aid flow (current US$) in Other small states in 2001 to that in 2005?
Keep it short and to the point. 0.76. What is the ratio of the Aid flow (current US$) of Burundi in 2001 to that in 2005?
Provide a short and direct response. 0.84. What is the ratio of the Aid flow (current US$) of Congo (Republic) in 2001 to that in 2005?
Provide a succinct answer. 0.01. What is the ratio of the Aid flow (current US$) of High income: nonOECD in 2002 to that in 2003?
Your answer should be compact. 1.24. What is the ratio of the Aid flow (current US$) in Other small states in 2002 to that in 2003?
Offer a terse response. 0.68. What is the ratio of the Aid flow (current US$) in Burundi in 2002 to that in 2003?
Ensure brevity in your answer.  0.74. What is the ratio of the Aid flow (current US$) of High income: nonOECD in 2002 to that in 2004?
Ensure brevity in your answer.  1.3. What is the ratio of the Aid flow (current US$) in Other small states in 2002 to that in 2004?
Offer a very short reply. 0.61. What is the ratio of the Aid flow (current US$) in Burundi in 2002 to that in 2004?
Your response must be concise. 0.5. What is the ratio of the Aid flow (current US$) in Congo (Republic) in 2002 to that in 2004?
Keep it short and to the point. 1.8. What is the ratio of the Aid flow (current US$) of High income: nonOECD in 2002 to that in 2005?
Provide a short and direct response. 26.07. What is the ratio of the Aid flow (current US$) in Other small states in 2002 to that in 2005?
Ensure brevity in your answer.  1.02. What is the ratio of the Aid flow (current US$) in Burundi in 2002 to that in 2005?
Give a very brief answer. 0.53. What is the ratio of the Aid flow (current US$) of Congo (Republic) in 2002 to that in 2005?
Provide a succinct answer. 0.03. What is the ratio of the Aid flow (current US$) in High income: nonOECD in 2003 to that in 2004?
Offer a terse response. 1.04. What is the ratio of the Aid flow (current US$) of Other small states in 2003 to that in 2004?
Offer a very short reply. 0.9. What is the ratio of the Aid flow (current US$) in Burundi in 2003 to that in 2004?
Your answer should be very brief. 0.67. What is the ratio of the Aid flow (current US$) of High income: nonOECD in 2003 to that in 2005?
Keep it short and to the point. 21.03. What is the ratio of the Aid flow (current US$) of Other small states in 2003 to that in 2005?
Make the answer very short. 1.49. What is the ratio of the Aid flow (current US$) of Burundi in 2003 to that in 2005?
Make the answer very short. 0.71. What is the ratio of the Aid flow (current US$) in Congo (Republic) in 2003 to that in 2005?
Your answer should be very brief. 0. What is the ratio of the Aid flow (current US$) of High income: nonOECD in 2004 to that in 2005?
Offer a very short reply. 20.13. What is the ratio of the Aid flow (current US$) in Other small states in 2004 to that in 2005?
Provide a succinct answer. 1.66. What is the ratio of the Aid flow (current US$) in Burundi in 2004 to that in 2005?
Offer a terse response. 1.06. What is the ratio of the Aid flow (current US$) in Congo (Republic) in 2004 to that in 2005?
Keep it short and to the point. 0.02. What is the difference between the highest and the second highest Aid flow (current US$) of High income: nonOECD?
Your answer should be very brief. 3.43e+06. What is the difference between the highest and the second highest Aid flow (current US$) of Other small states?
Give a very brief answer. 1.04e+06. What is the difference between the highest and the second highest Aid flow (current US$) of Burundi?
Keep it short and to the point. 2.80e+05. What is the difference between the highest and the second highest Aid flow (current US$) of Congo (Republic)?
Offer a terse response. 1.13e+07. What is the difference between the highest and the lowest Aid flow (current US$) in High income: nonOECD?
Your answer should be very brief. 1.70e+07. What is the difference between the highest and the lowest Aid flow (current US$) in Other small states?
Provide a short and direct response. 6.59e+06. What is the difference between the highest and the lowest Aid flow (current US$) in Burundi?
Your answer should be compact. 2.47e+06. What is the difference between the highest and the lowest Aid flow (current US$) in Congo (Republic)?
Provide a succinct answer. 1.19e+07. 